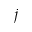Convert formula to latex. <formula><loc_0><loc_0><loc_500><loc_500>j</formula> 